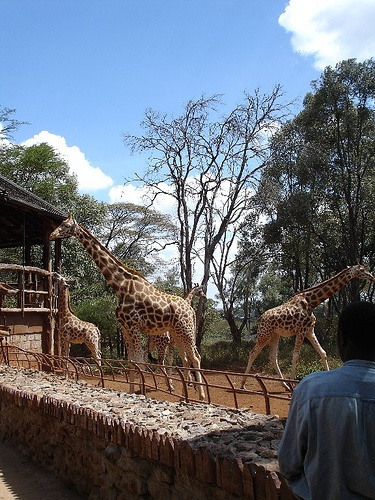Describe the objects in this image and their specific colors. I can see people in lightblue, black, navy, darkblue, and gray tones, giraffe in lightblue, black, maroon, and gray tones, giraffe in lightblue, black, maroon, and gray tones, giraffe in lightblue, maroon, black, and gray tones, and giraffe in lightblue, maroon, black, and gray tones in this image. 